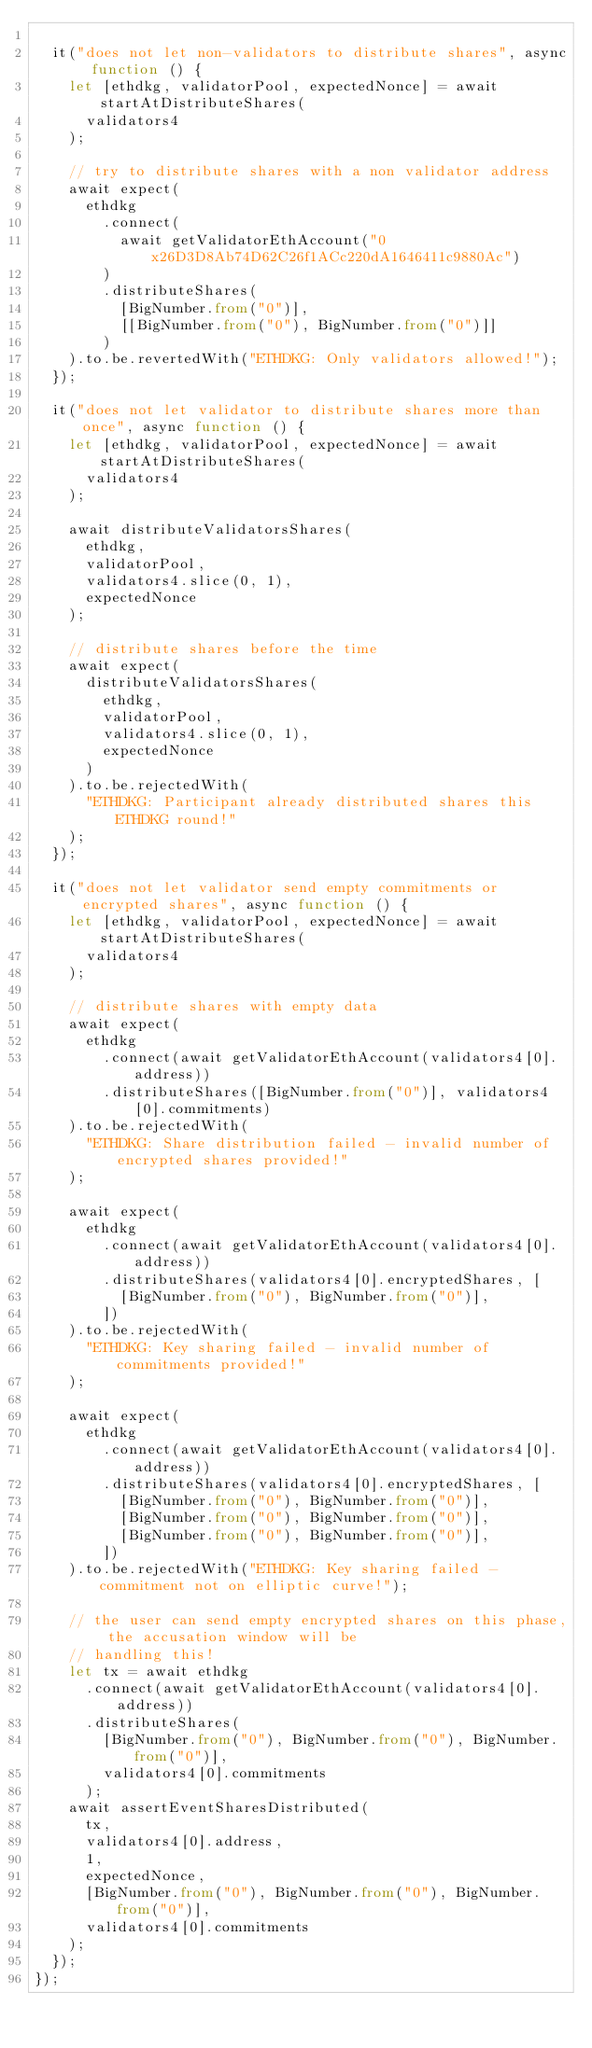<code> <loc_0><loc_0><loc_500><loc_500><_TypeScript_>
  it("does not let non-validators to distribute shares", async function () {
    let [ethdkg, validatorPool, expectedNonce] = await startAtDistributeShares(
      validators4
    );

    // try to distribute shares with a non validator address
    await expect(
      ethdkg
        .connect(
          await getValidatorEthAccount("0x26D3D8Ab74D62C26f1ACc220dA1646411c9880Ac")
        )
        .distributeShares(
          [BigNumber.from("0")],
          [[BigNumber.from("0"), BigNumber.from("0")]]
        )
    ).to.be.revertedWith("ETHDKG: Only validators allowed!");
  });

  it("does not let validator to distribute shares more than once", async function () {
    let [ethdkg, validatorPool, expectedNonce] = await startAtDistributeShares(
      validators4
    );

    await distributeValidatorsShares(
      ethdkg,
      validatorPool,
      validators4.slice(0, 1),
      expectedNonce
    );

    // distribute shares before the time
    await expect(
      distributeValidatorsShares(
        ethdkg,
        validatorPool,
        validators4.slice(0, 1),
        expectedNonce
      )
    ).to.be.rejectedWith(
      "ETHDKG: Participant already distributed shares this ETHDKG round!"
    );
  });

  it("does not let validator send empty commitments or encrypted shares", async function () {
    let [ethdkg, validatorPool, expectedNonce] = await startAtDistributeShares(
      validators4
    );

    // distribute shares with empty data
    await expect(
      ethdkg
        .connect(await getValidatorEthAccount(validators4[0].address))
        .distributeShares([BigNumber.from("0")], validators4[0].commitments)
    ).to.be.rejectedWith(
      "ETHDKG: Share distribution failed - invalid number of encrypted shares provided!"
    );

    await expect(
      ethdkg
        .connect(await getValidatorEthAccount(validators4[0].address))
        .distributeShares(validators4[0].encryptedShares, [
          [BigNumber.from("0"), BigNumber.from("0")],
        ])
    ).to.be.rejectedWith(
      "ETHDKG: Key sharing failed - invalid number of commitments provided!"
    );

    await expect(
      ethdkg
        .connect(await getValidatorEthAccount(validators4[0].address))
        .distributeShares(validators4[0].encryptedShares, [
          [BigNumber.from("0"), BigNumber.from("0")],
          [BigNumber.from("0"), BigNumber.from("0")],
          [BigNumber.from("0"), BigNumber.from("0")],
        ])
    ).to.be.rejectedWith("ETHDKG: Key sharing failed - commitment not on elliptic curve!");

    // the user can send empty encrypted shares on this phase, the accusation window will be
    // handling this!
    let tx = await ethdkg
      .connect(await getValidatorEthAccount(validators4[0].address))
      .distributeShares(
        [BigNumber.from("0"), BigNumber.from("0"), BigNumber.from("0")],
        validators4[0].commitments
      );
    await assertEventSharesDistributed(
      tx,
      validators4[0].address,
      1,
      expectedNonce,
      [BigNumber.from("0"), BigNumber.from("0"), BigNumber.from("0")],
      validators4[0].commitments
    );
  });
});
</code> 